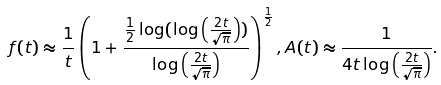<formula> <loc_0><loc_0><loc_500><loc_500>f ( t ) \approx \frac { 1 } { t } \left ( 1 + \frac { \frac { 1 } { 2 } \log ( \log \left ( \frac { 2 t } { \sqrt { \pi } } \right ) ) } { \log \left ( \frac { 2 t } { \sqrt { \pi } } \right ) } \right ) ^ { \frac { 1 } { 2 } } , A ( t ) \approx \frac { 1 } { 4 t \log \left ( \frac { 2 t } { \sqrt { \pi } } \right ) } .</formula> 